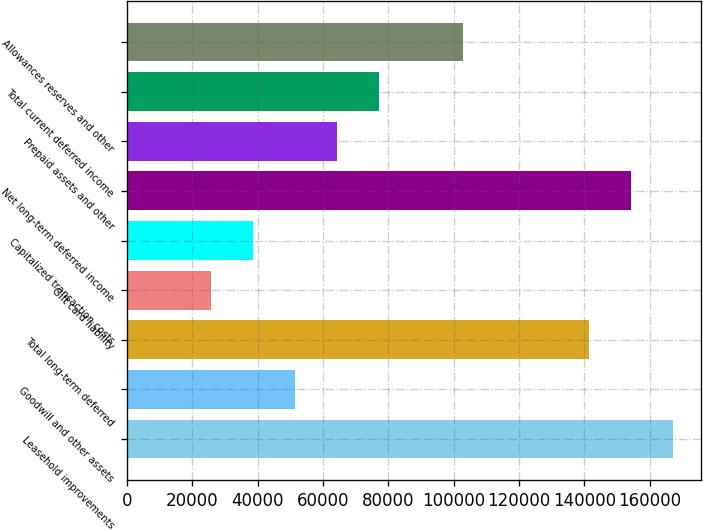Convert chart to OTSL. <chart><loc_0><loc_0><loc_500><loc_500><bar_chart><fcel>Leasehold improvements<fcel>Goodwill and other assets<fcel>Total long-term deferred<fcel>Gift card liability<fcel>Capitalized transaction costs<fcel>Net long-term deferred income<fcel>Prepaid assets and other<fcel>Total current deferred income<fcel>Allowances reserves and other<nl><fcel>167272<fcel>51543.2<fcel>141555<fcel>25825.6<fcel>38684.4<fcel>154414<fcel>64402<fcel>77260.8<fcel>102978<nl></chart> 